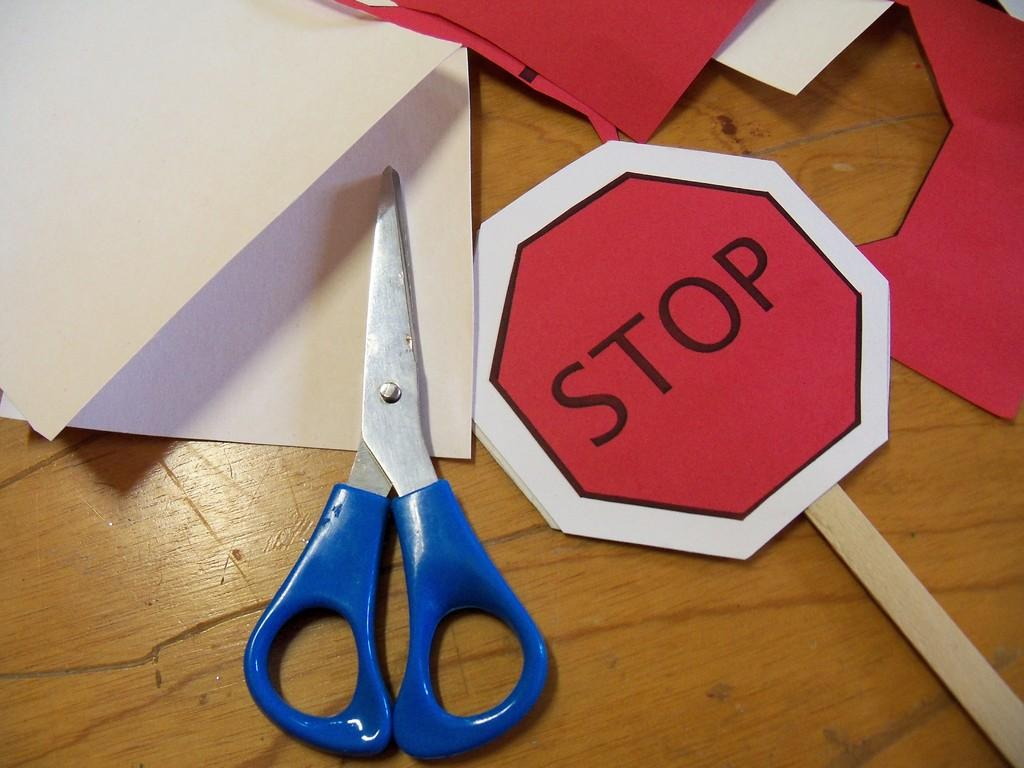<image>
Share a concise interpretation of the image provided. There's a paper stop sign besides a scissor 